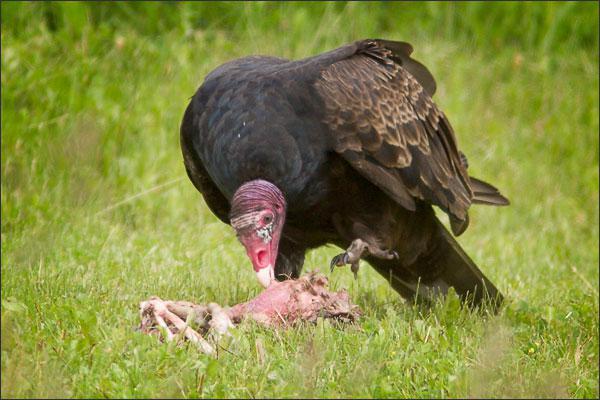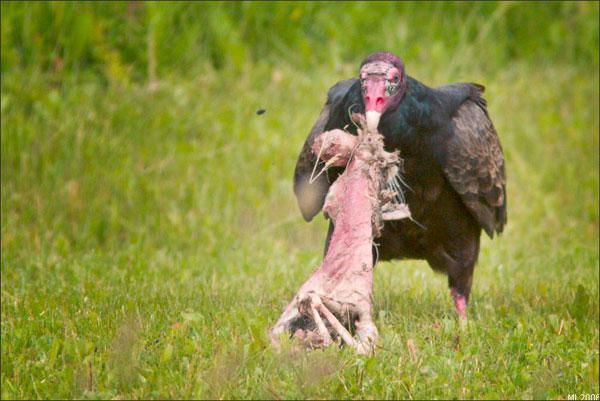The first image is the image on the left, the second image is the image on the right. For the images shown, is this caption "There are two vultures eating in the images." true? Answer yes or no. Yes. The first image is the image on the left, the second image is the image on the right. Given the left and right images, does the statement "in the right side pic the bird has something it its mouth" hold true? Answer yes or no. Yes. 